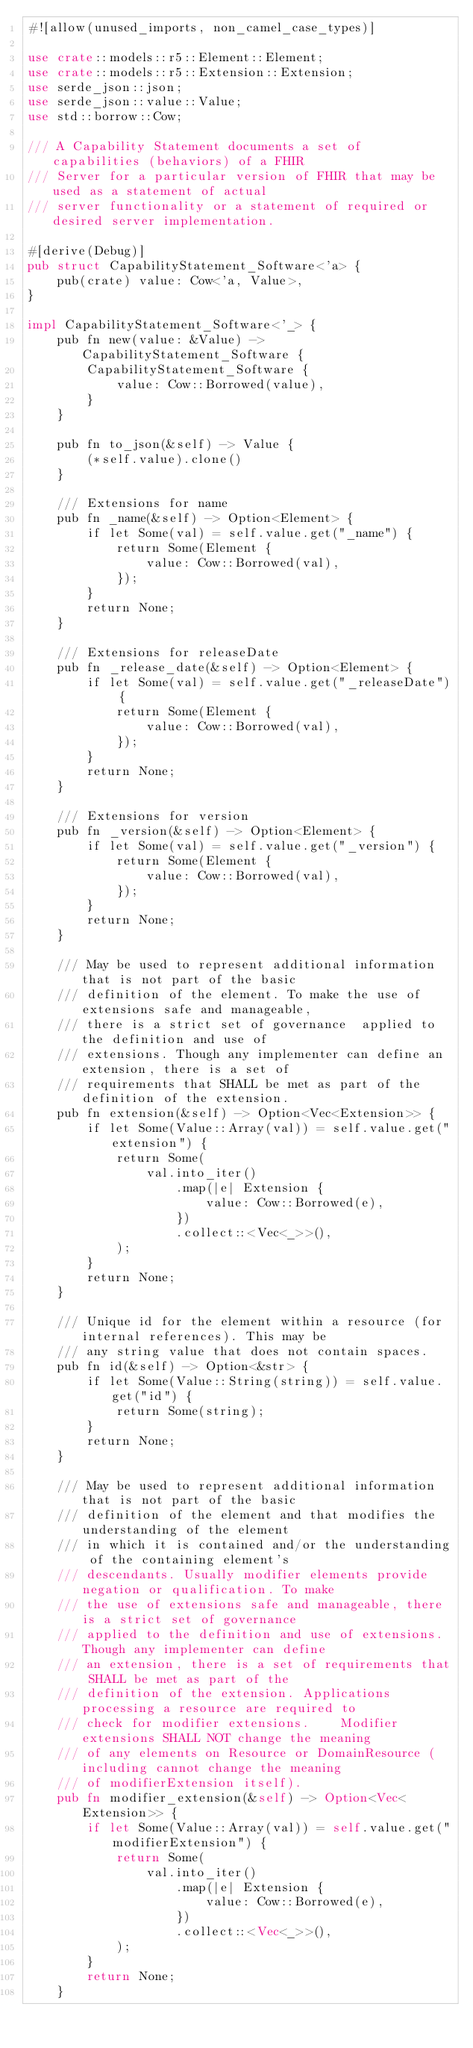Convert code to text. <code><loc_0><loc_0><loc_500><loc_500><_Rust_>#![allow(unused_imports, non_camel_case_types)]

use crate::models::r5::Element::Element;
use crate::models::r5::Extension::Extension;
use serde_json::json;
use serde_json::value::Value;
use std::borrow::Cow;

/// A Capability Statement documents a set of capabilities (behaviors) of a FHIR
/// Server for a particular version of FHIR that may be used as a statement of actual
/// server functionality or a statement of required or desired server implementation.

#[derive(Debug)]
pub struct CapabilityStatement_Software<'a> {
    pub(crate) value: Cow<'a, Value>,
}

impl CapabilityStatement_Software<'_> {
    pub fn new(value: &Value) -> CapabilityStatement_Software {
        CapabilityStatement_Software {
            value: Cow::Borrowed(value),
        }
    }

    pub fn to_json(&self) -> Value {
        (*self.value).clone()
    }

    /// Extensions for name
    pub fn _name(&self) -> Option<Element> {
        if let Some(val) = self.value.get("_name") {
            return Some(Element {
                value: Cow::Borrowed(val),
            });
        }
        return None;
    }

    /// Extensions for releaseDate
    pub fn _release_date(&self) -> Option<Element> {
        if let Some(val) = self.value.get("_releaseDate") {
            return Some(Element {
                value: Cow::Borrowed(val),
            });
        }
        return None;
    }

    /// Extensions for version
    pub fn _version(&self) -> Option<Element> {
        if let Some(val) = self.value.get("_version") {
            return Some(Element {
                value: Cow::Borrowed(val),
            });
        }
        return None;
    }

    /// May be used to represent additional information that is not part of the basic
    /// definition of the element. To make the use of extensions safe and manageable,
    /// there is a strict set of governance  applied to the definition and use of
    /// extensions. Though any implementer can define an extension, there is a set of
    /// requirements that SHALL be met as part of the definition of the extension.
    pub fn extension(&self) -> Option<Vec<Extension>> {
        if let Some(Value::Array(val)) = self.value.get("extension") {
            return Some(
                val.into_iter()
                    .map(|e| Extension {
                        value: Cow::Borrowed(e),
                    })
                    .collect::<Vec<_>>(),
            );
        }
        return None;
    }

    /// Unique id for the element within a resource (for internal references). This may be
    /// any string value that does not contain spaces.
    pub fn id(&self) -> Option<&str> {
        if let Some(Value::String(string)) = self.value.get("id") {
            return Some(string);
        }
        return None;
    }

    /// May be used to represent additional information that is not part of the basic
    /// definition of the element and that modifies the understanding of the element
    /// in which it is contained and/or the understanding of the containing element's
    /// descendants. Usually modifier elements provide negation or qualification. To make
    /// the use of extensions safe and manageable, there is a strict set of governance
    /// applied to the definition and use of extensions. Though any implementer can define
    /// an extension, there is a set of requirements that SHALL be met as part of the
    /// definition of the extension. Applications processing a resource are required to
    /// check for modifier extensions.    Modifier extensions SHALL NOT change the meaning
    /// of any elements on Resource or DomainResource (including cannot change the meaning
    /// of modifierExtension itself).
    pub fn modifier_extension(&self) -> Option<Vec<Extension>> {
        if let Some(Value::Array(val)) = self.value.get("modifierExtension") {
            return Some(
                val.into_iter()
                    .map(|e| Extension {
                        value: Cow::Borrowed(e),
                    })
                    .collect::<Vec<_>>(),
            );
        }
        return None;
    }
</code> 